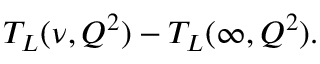Convert formula to latex. <formula><loc_0><loc_0><loc_500><loc_500>T _ { L } ( \nu , Q ^ { 2 } ) - T _ { L } ( \infty , Q ^ { 2 } ) .</formula> 